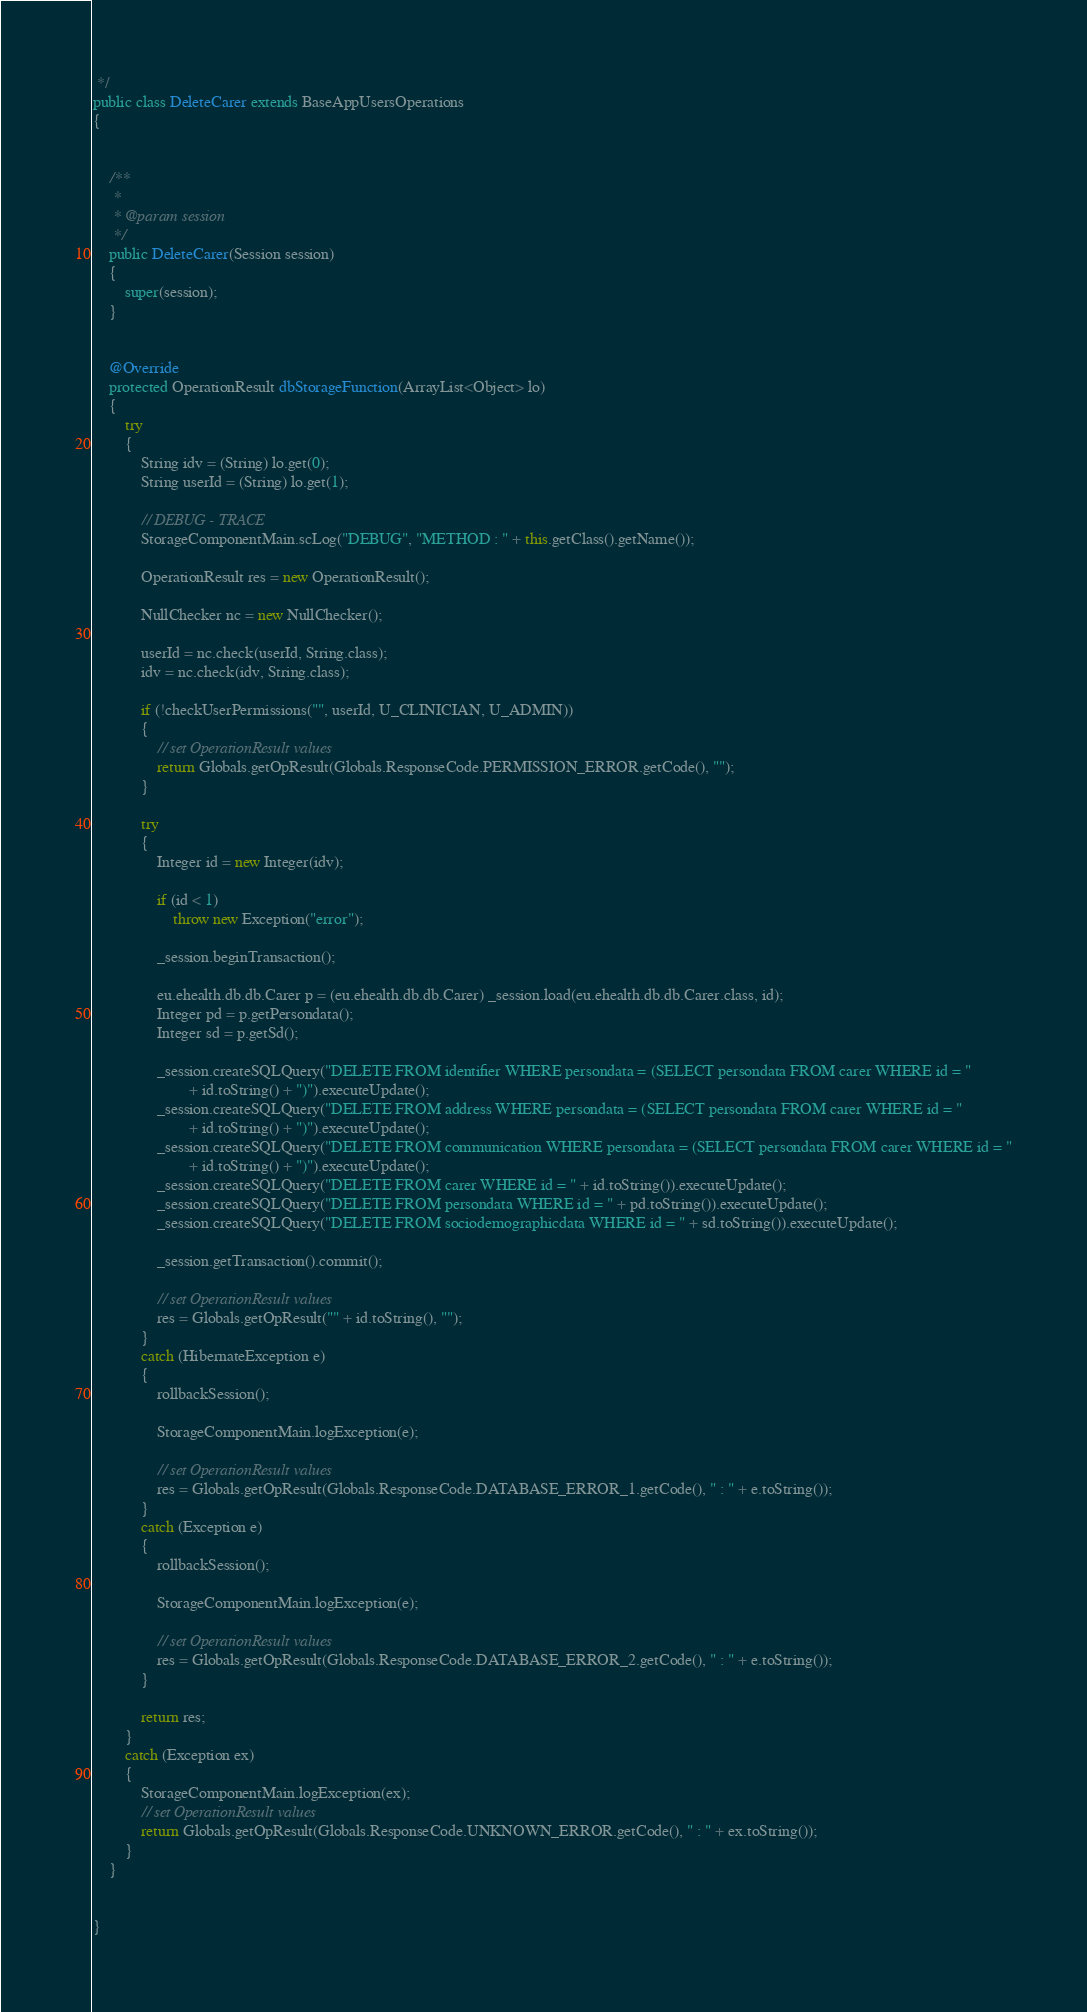Convert code to text. <code><loc_0><loc_0><loc_500><loc_500><_Java_> */
public class DeleteCarer extends BaseAppUsersOperations
{

	
	/**
	 * 
	 * @param session
	 */
	public DeleteCarer(Session session)
	{
		super(session);
	}

	
	@Override
	protected OperationResult dbStorageFunction(ArrayList<Object> lo)
	{
		try
		{
			String idv = (String) lo.get(0);
			String userId = (String) lo.get(1);
			
			// DEBUG - TRACE
			StorageComponentMain.scLog("DEBUG", "METHOD : " + this.getClass().getName());			
			
			OperationResult res = new OperationResult();

			NullChecker nc = new NullChecker();

			userId = nc.check(userId, String.class);
			idv = nc.check(idv, String.class);

			if (!checkUserPermissions("", userId, U_CLINICIAN, U_ADMIN))
			{
				// set OperationResult values
				return Globals.getOpResult(Globals.ResponseCode.PERMISSION_ERROR.getCode(), "");
			}

			try
			{
				Integer id = new Integer(idv);

				if (id < 1)
					throw new Exception("error");

				_session.beginTransaction();

				eu.ehealth.db.db.Carer p = (eu.ehealth.db.db.Carer) _session.load(eu.ehealth.db.db.Carer.class, id);
				Integer pd = p.getPersondata();
				Integer sd = p.getSd();

				_session.createSQLQuery("DELETE FROM identifier WHERE persondata = (SELECT persondata FROM carer WHERE id = "
						+ id.toString() + ")").executeUpdate();
				_session.createSQLQuery("DELETE FROM address WHERE persondata = (SELECT persondata FROM carer WHERE id = "
						+ id.toString() + ")").executeUpdate();
				_session.createSQLQuery("DELETE FROM communication WHERE persondata = (SELECT persondata FROM carer WHERE id = "
						+ id.toString() + ")").executeUpdate();
				_session.createSQLQuery("DELETE FROM carer WHERE id = " + id.toString()).executeUpdate();
				_session.createSQLQuery("DELETE FROM persondata WHERE id = " + pd.toString()).executeUpdate();
				_session.createSQLQuery("DELETE FROM sociodemographicdata WHERE id = " + sd.toString()).executeUpdate();

				_session.getTransaction().commit();

				// set OperationResult values
				res = Globals.getOpResult("" + id.toString(), "");
			}
			catch (HibernateException e)
			{
				rollbackSession();

				StorageComponentMain.logException(e);

				// set OperationResult values
				res = Globals.getOpResult(Globals.ResponseCode.DATABASE_ERROR_1.getCode(), " : " + e.toString());
			}
			catch (Exception e)
			{
				rollbackSession();

				StorageComponentMain.logException(e);

				// set OperationResult values
				res = Globals.getOpResult(Globals.ResponseCode.DATABASE_ERROR_2.getCode(), " : " + e.toString());
			}

			return res;
		}
		catch (Exception ex)
		{
			StorageComponentMain.logException(ex);
			// set OperationResult values
			return Globals.getOpResult(Globals.ResponseCode.UNKNOWN_ERROR.getCode(), " : " + ex.toString());
		}
	}

	
}
</code> 